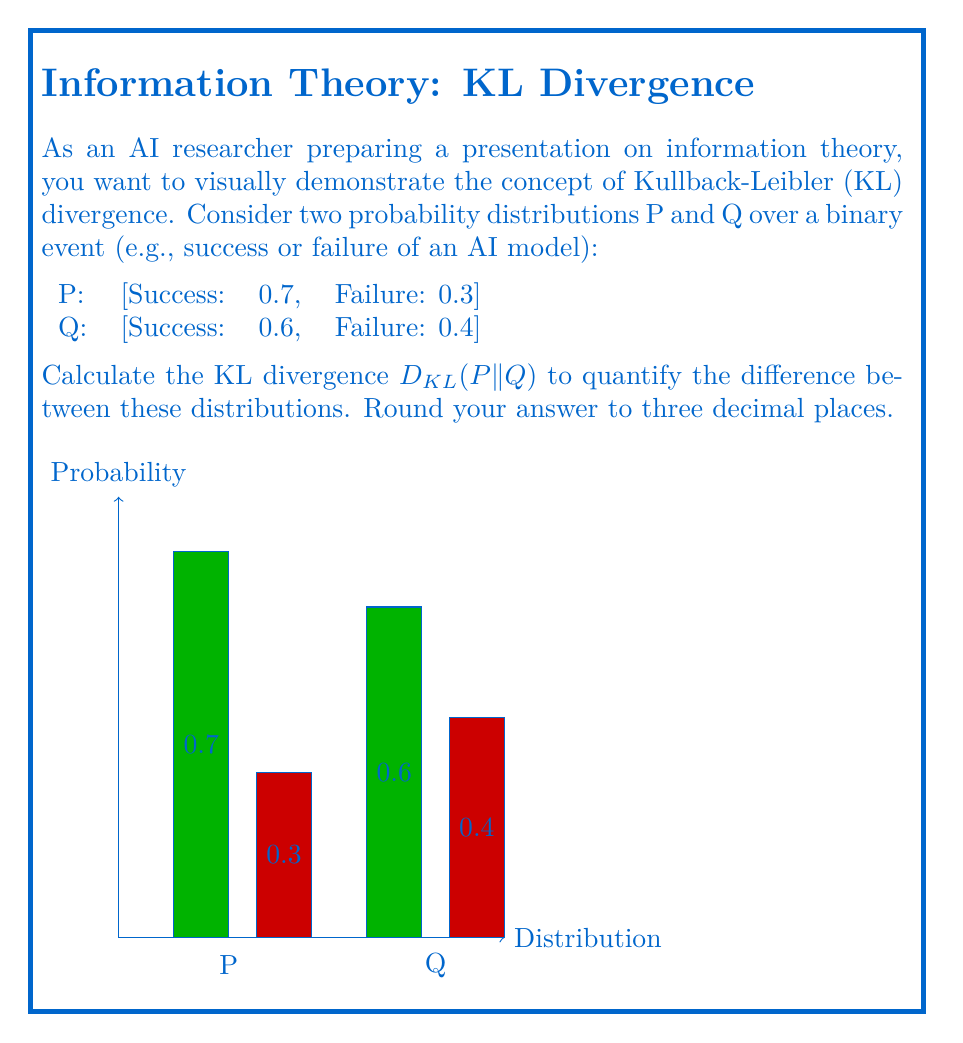Help me with this question. To calculate the Kullback-Leibler divergence between probability distributions P and Q, we use the formula:

$$D_{KL}(P||Q) = \sum_{i} P(i) \log\left(\frac{P(i)}{Q(i)}\right)$$

Where $i$ represents each possible outcome.

Step 1: Identify the probabilities for each outcome:
P(success) = 0.7, P(failure) = 0.3
Q(success) = 0.6, Q(failure) = 0.4

Step 2: Calculate the contribution for the "success" outcome:
$$0.7 \log\left(\frac{0.7}{0.6}\right) = 0.7 \log(1.1667) = 0.7 \times 0.1542 = 0.1079$$

Step 3: Calculate the contribution for the "failure" outcome:
$$0.3 \log\left(\frac{0.3}{0.4}\right) = 0.3 \log(0.75) = 0.3 \times (-0.2877) = -0.0863$$

Step 4: Sum the contributions:
$$D_{KL}(P||Q) = 0.1079 + (-0.0863) = 0.0216$$

Step 5: Round to three decimal places:
$$D_{KL}(P||Q) \approx 0.022$$

This result quantifies the information lost when using distribution Q to approximate distribution P, which can be visually represented in the presentation to enhance understanding.
Answer: $D_{KL}(P||Q) \approx 0.022$ 